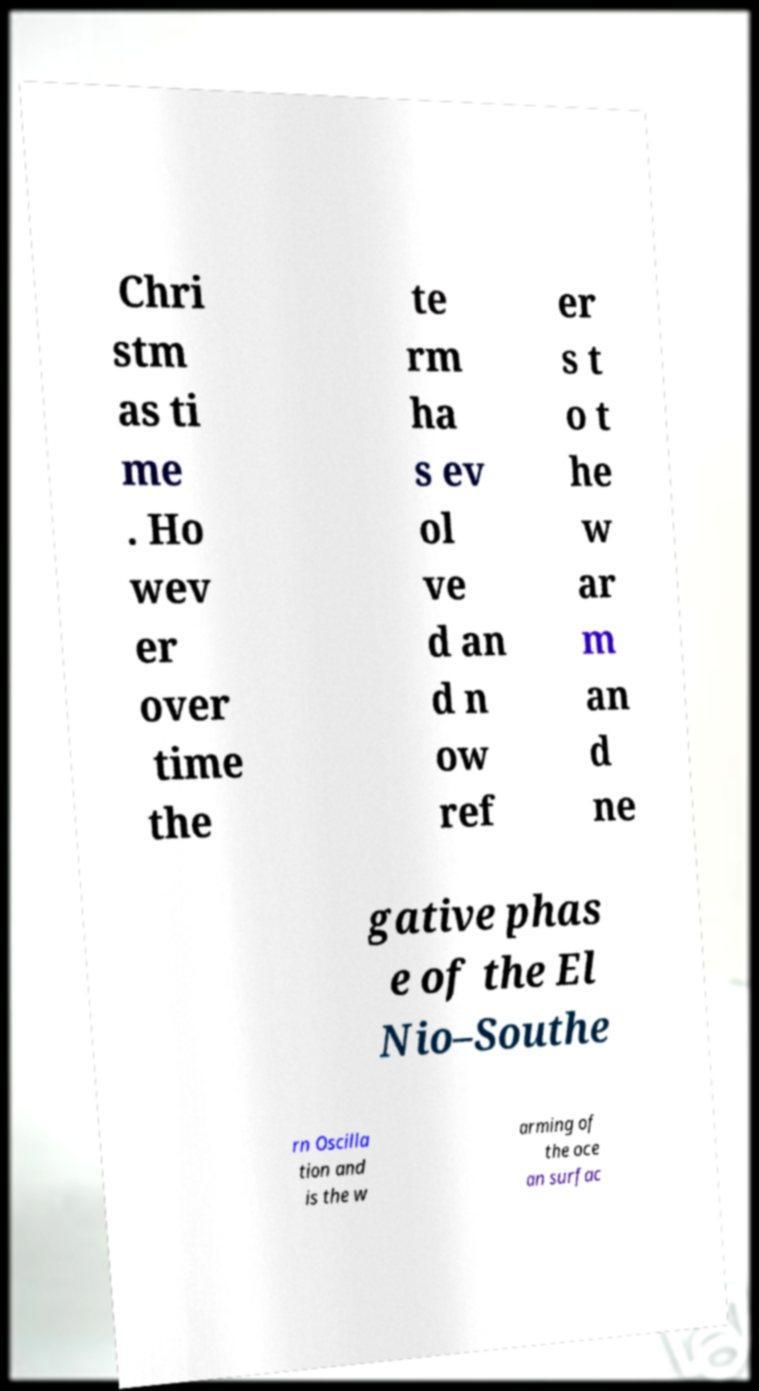Can you accurately transcribe the text from the provided image for me? Chri stm as ti me . Ho wev er over time the te rm ha s ev ol ve d an d n ow ref er s t o t he w ar m an d ne gative phas e of the El Nio–Southe rn Oscilla tion and is the w arming of the oce an surfac 